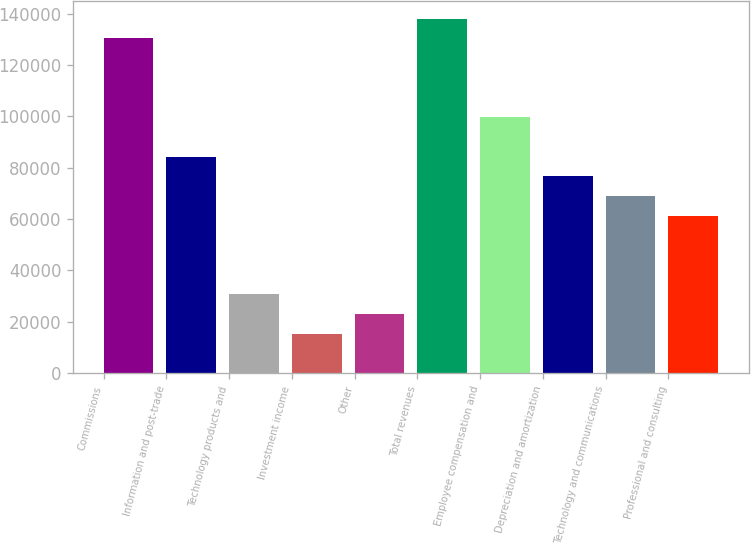Convert chart to OTSL. <chart><loc_0><loc_0><loc_500><loc_500><bar_chart><fcel>Commissions<fcel>Information and post-trade<fcel>Technology products and<fcel>Investment income<fcel>Other<fcel>Total revenues<fcel>Employee compensation and<fcel>Depreciation and amortization<fcel>Technology and communications<fcel>Professional and consulting<nl><fcel>130294<fcel>84308.4<fcel>30658<fcel>15329.3<fcel>22993.7<fcel>137959<fcel>99637<fcel>76644<fcel>68979.7<fcel>61315.3<nl></chart> 